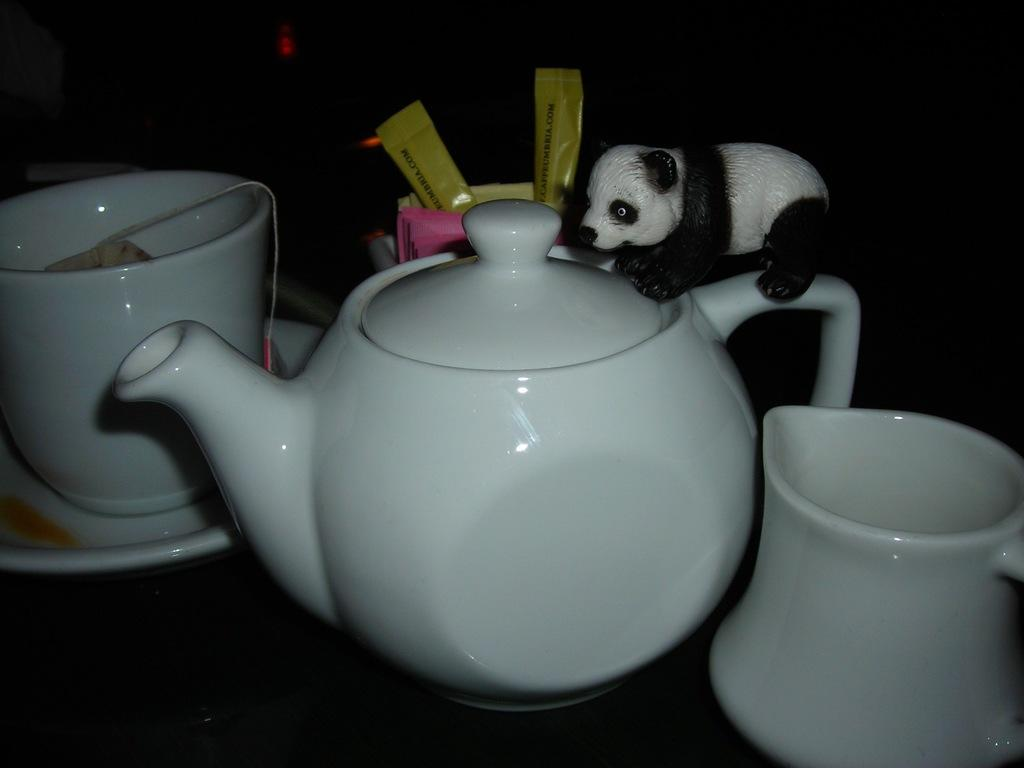What is the main object in the image? There is a teapot in the image. How many cups are visible in the image? There are two cups in the image. What additional item can be seen on top of the teapot? There is a panda toy on top of the teapot. What word is being spelled out by the cups in the image? There is no indication in the image that the cups are being used to spell out a word. Is there a recess in the teapot where the panda toy can be stored? The image does not provide information about the teapot's internal structure, so it cannot be determined if there is a recess for the panda toy. 